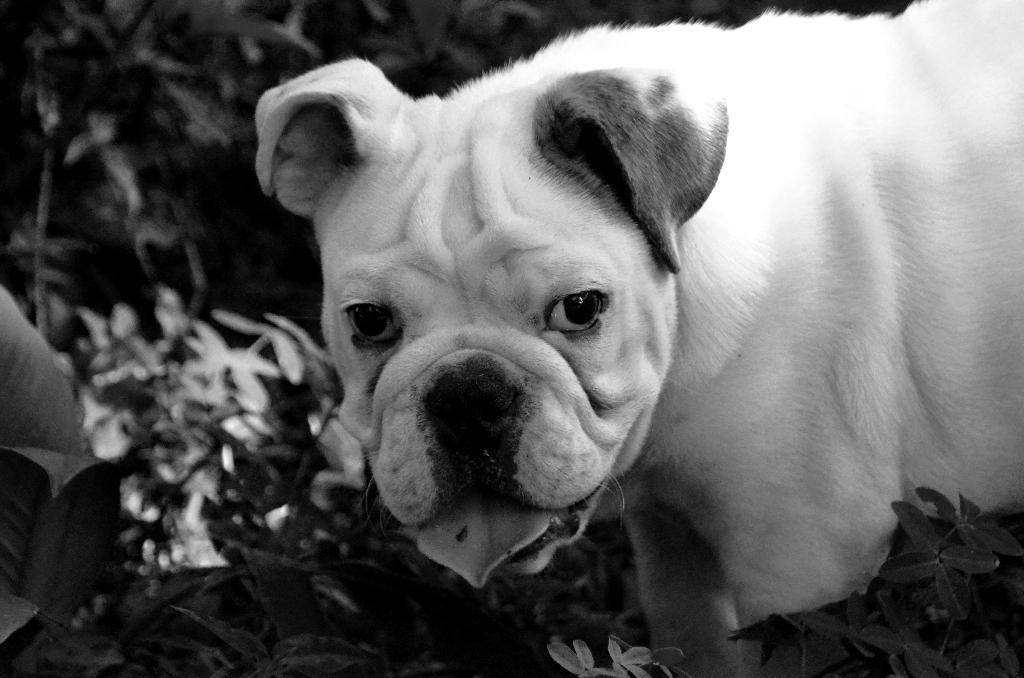What is the color scheme of the image? The image is black and white. What animal can be seen in the image? There is a dog in the image. What type of vegetation is present in the image? There are plants in the image. How would you describe the background of the image? The background of the image is blurred. What type of celery is being harvested in the image? There is no celery present in the image, and no harvesting is taking place. 